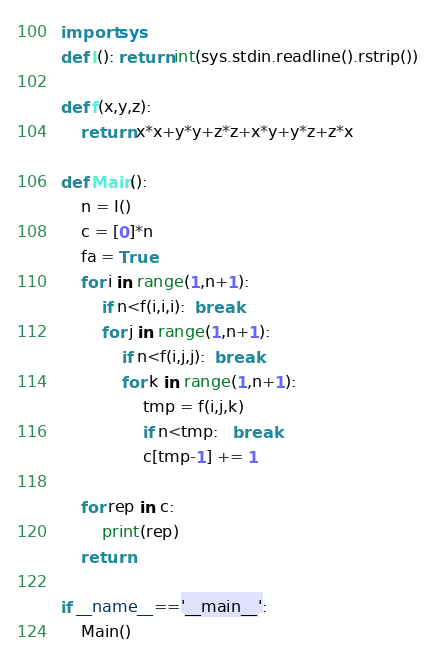Convert code to text. <code><loc_0><loc_0><loc_500><loc_500><_Python_>import sys
def I(): return int(sys.stdin.readline().rstrip())

def f(x,y,z):
    return x*x+y*y+z*z+x*y+y*z+z*x

def Main():
    n = I()
    c = [0]*n
    fa = True
    for i in range(1,n+1):
        if n<f(i,i,i):  break
        for j in range(1,n+1):
            if n<f(i,j,j):  break
            for k in range(1,n+1):
                tmp = f(i,j,k)
                if n<tmp:   break
                c[tmp-1] += 1

    for rep in c:
        print(rep)
    return

if __name__=='__main__':
    Main()</code> 